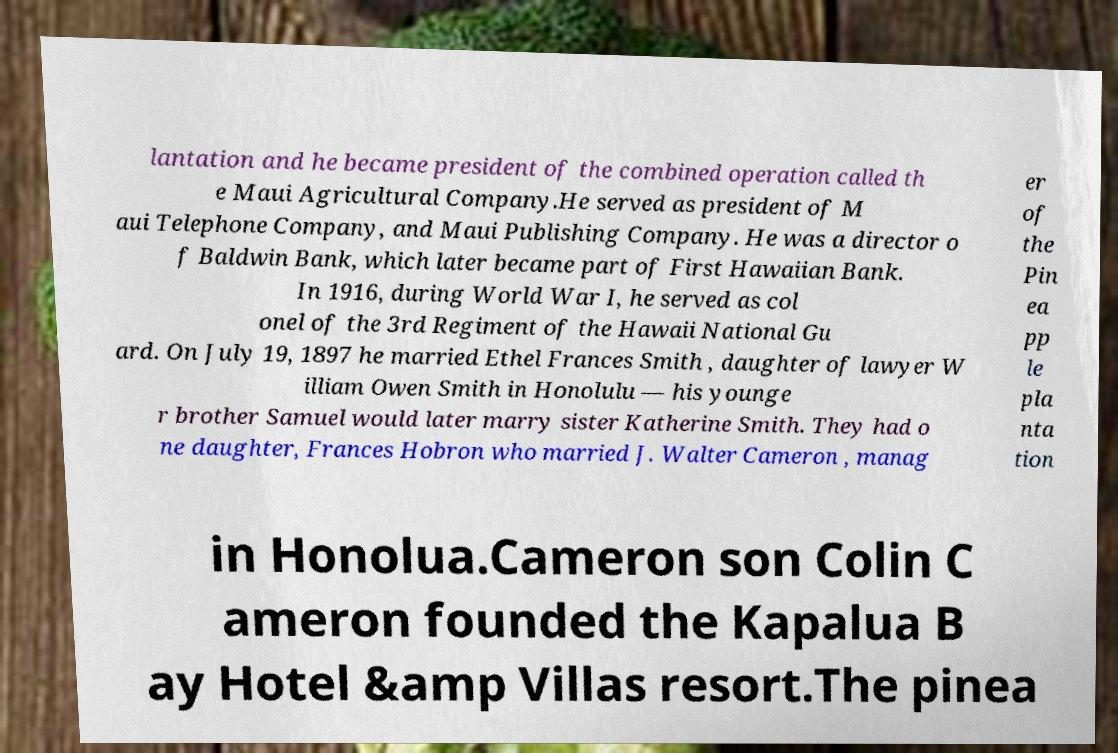Can you accurately transcribe the text from the provided image for me? lantation and he became president of the combined operation called th e Maui Agricultural Company.He served as president of M aui Telephone Company, and Maui Publishing Company. He was a director o f Baldwin Bank, which later became part of First Hawaiian Bank. In 1916, during World War I, he served as col onel of the 3rd Regiment of the Hawaii National Gu ard. On July 19, 1897 he married Ethel Frances Smith , daughter of lawyer W illiam Owen Smith in Honolulu — his younge r brother Samuel would later marry sister Katherine Smith. They had o ne daughter, Frances Hobron who married J. Walter Cameron , manag er of the Pin ea pp le pla nta tion in Honolua.Cameron son Colin C ameron founded the Kapalua B ay Hotel &amp Villas resort.The pinea 